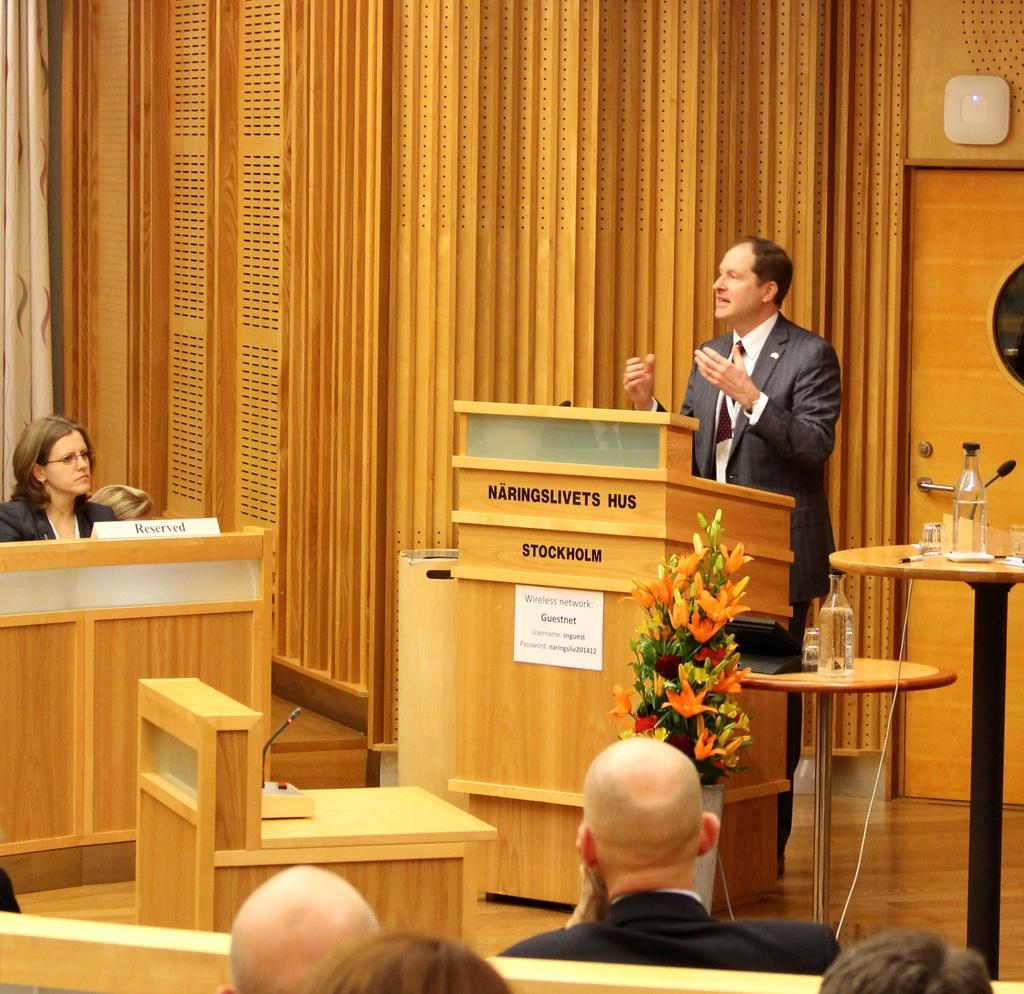What is the man in the image doing? The man is standing in front of a podium. How many tables are visible in the image? There are two tables in the image. What are the people in the image doing? There is a group of people sitting on a bench. What type of bread is being shared among the people on the bench? There is no bread present in the image; it only shows a man standing in front of a podium, two tables, and a group of people sitting on a bench. 